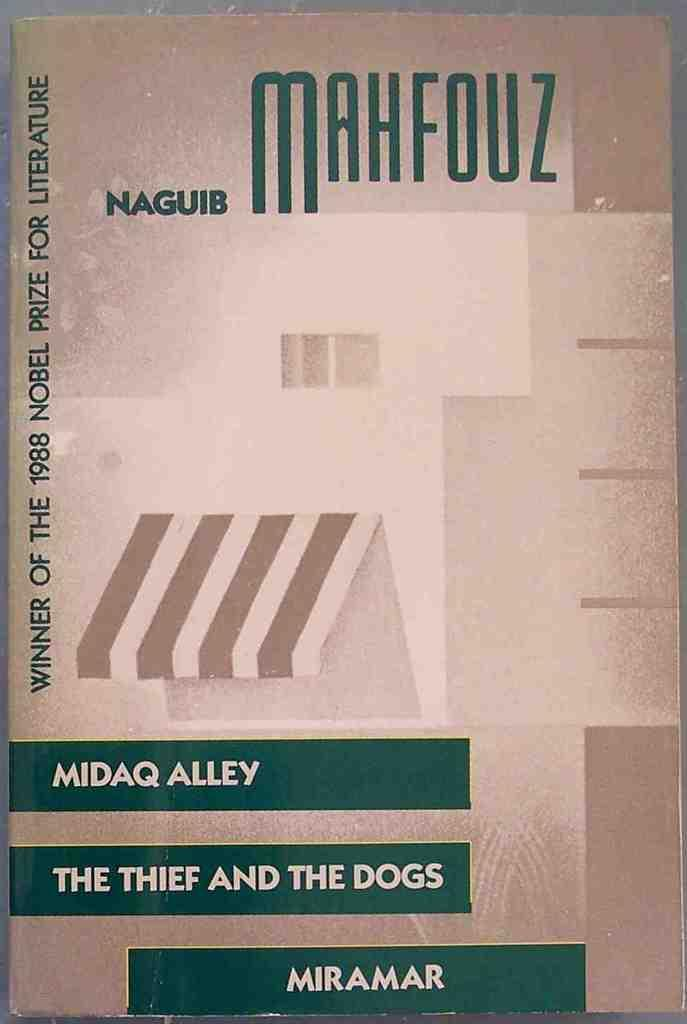<image>
Give a short and clear explanation of the subsequent image. Midaq Alley: The Thief and the Dogs by Naguib Mahfouz sits on a table. 